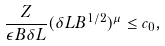Convert formula to latex. <formula><loc_0><loc_0><loc_500><loc_500>\frac { Z } { \epsilon B \delta L } ( \delta L B ^ { 1 / 2 } ) ^ { \mu } \leq c _ { 0 } ,</formula> 